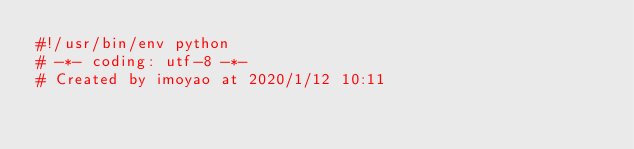Convert code to text. <code><loc_0><loc_0><loc_500><loc_500><_Python_>#!/usr/bin/env python
# -*- coding: utf-8 -*-
# Created by imoyao at 2020/1/12 10:11
</code> 